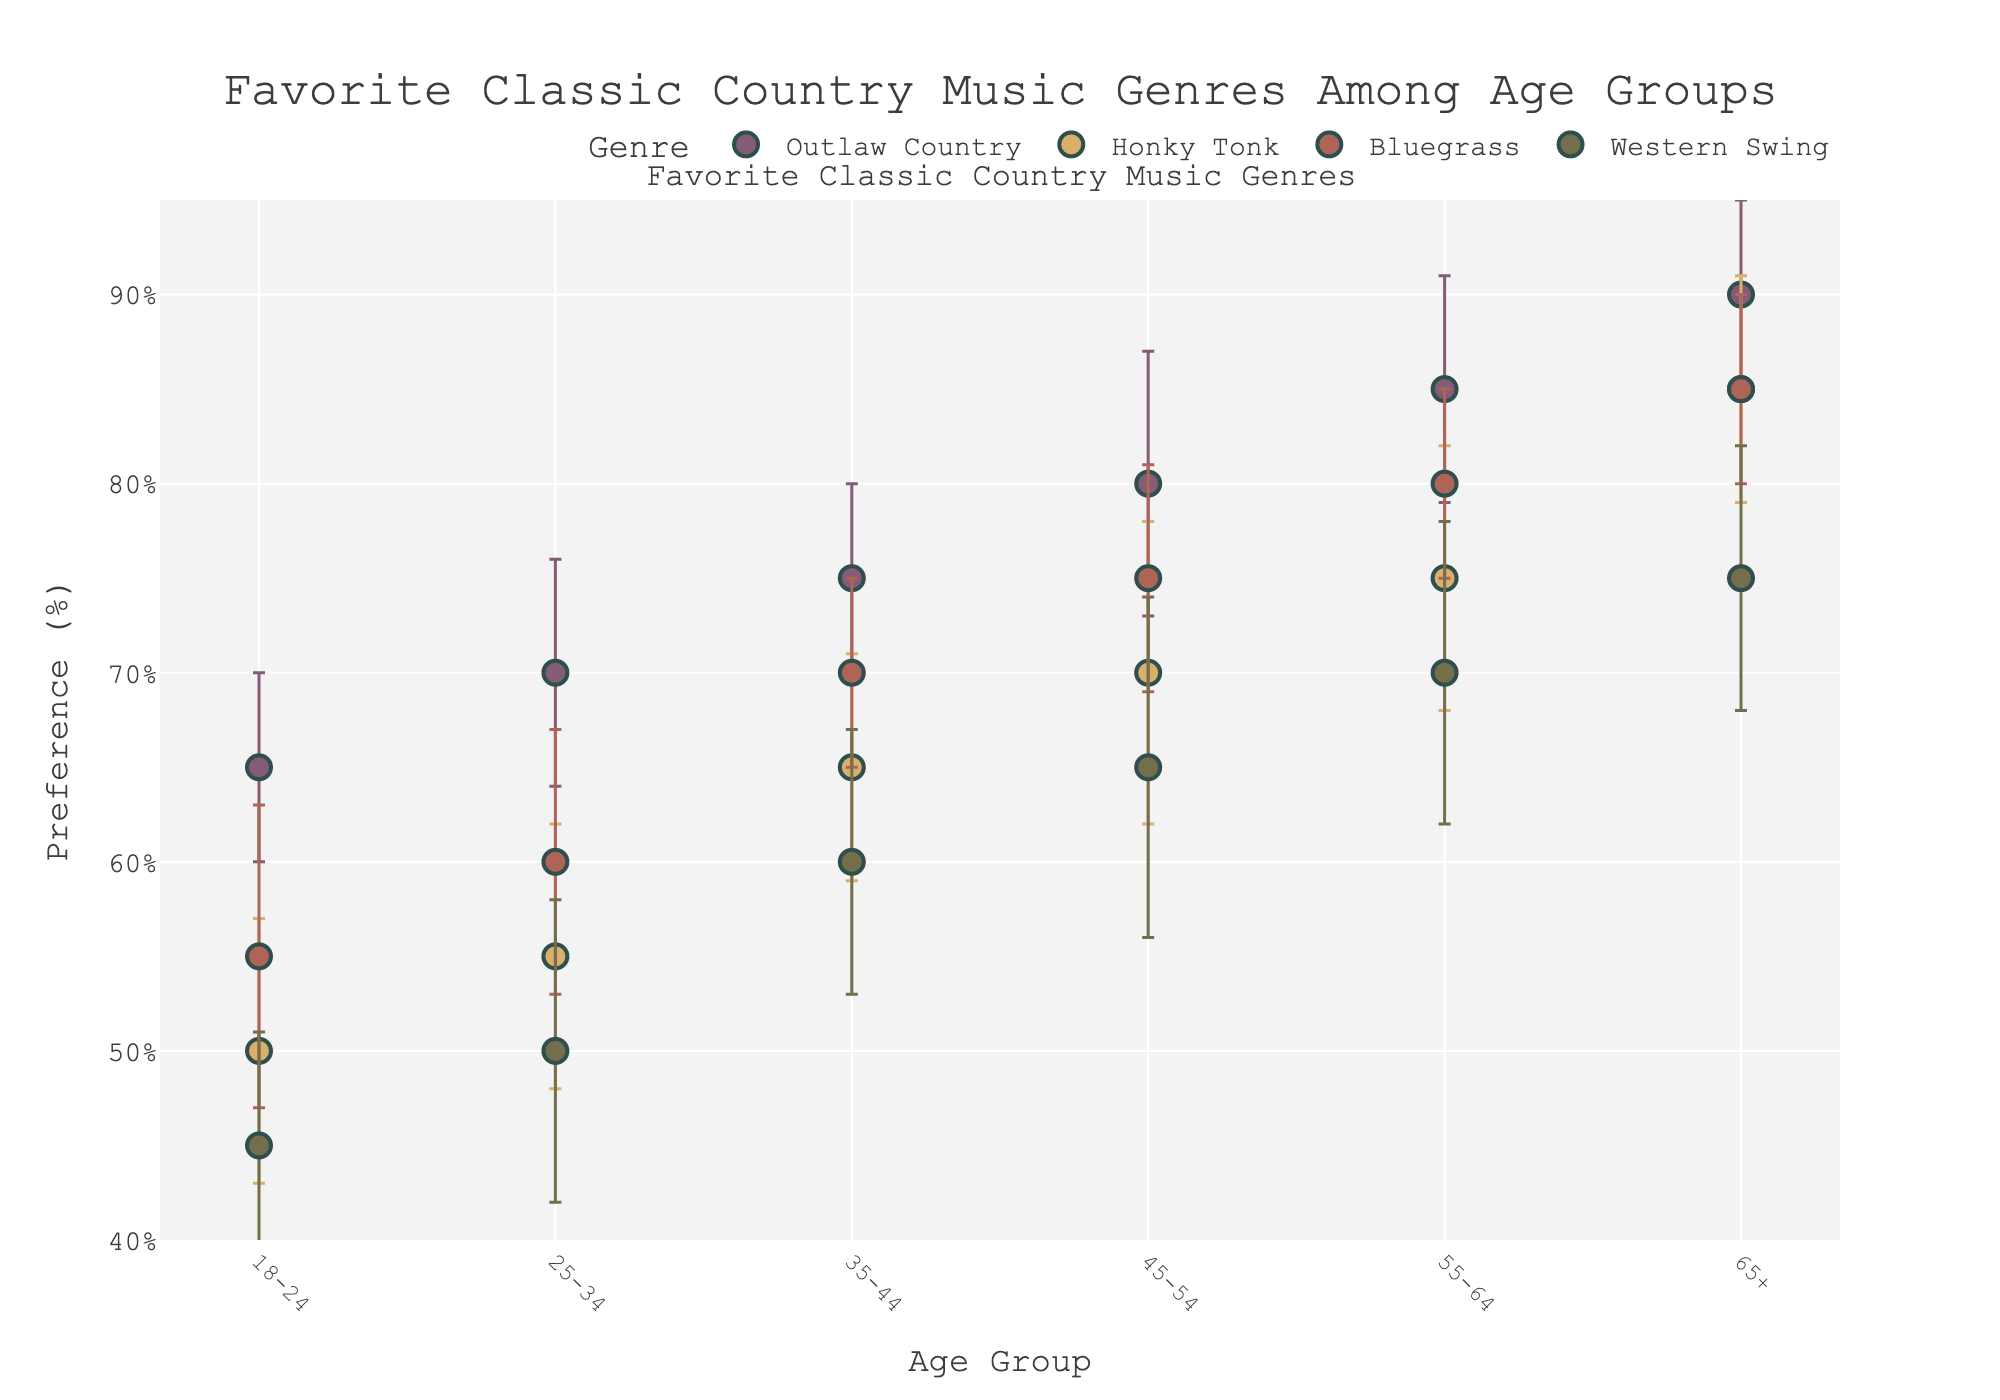Which age group has the highest preference for Outlaw Country? Look for the dot representing Outlaw Country and check the age group with the highest y-axis value.
Answer: 65+ What is the range of preference percentages for Western Swing across all age groups? Identify the highest and lowest preference values for Western Swing and subtract the lowest from the highest.
Answer: 45%-75% Which genre has the most consistent preference across different age groups, given the smallest error bars? Compare the error bar lengths for each genre across age groups to see which one has the smallest consistently.
Answer: Outlaw Country How does the preference for Bluegrass in the 35-44 age group compare to the 45-54 age group? Observe the y-axis values for Bluegrass in these two age groups and compare them.
Answer: 45-54 is higher Which region shows the highest mean preference for Honky Tonk among the age groups? Check each data point of Honky Tonk across regions and identify the highest mean preference value.
Answer: Midwest What's the difference in mean preference for Outlaw Country between the 25-34 and 55-64 age groups in the West region? Find the y-axis values for Outlaw Country in these age groups and calculate the difference.
Answer: 15 For the 18-24 age group, which genre has the lowest preference and what is the value? Look for the dots representing the 18-24 age group and identify the genre with the lowest y-axis value.
Answer: Western Swing, 45 Which genre's preference shows the greatest increase from the 18-24 to 65+ age group? Compare the preference values from 18-24 to 65+ for each genre and determine the greatest increase.
Answer: Outlaw Country How does the preference for Honky Tonk in the 55-64 age group relate to the preference for Bluegrass in the same age group? Compare the y-axis preference values for Honky Tonk and Bluegrass within the 55-64 age group.
Answer: Bluegrass is higher 